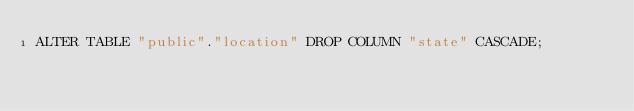Convert code to text. <code><loc_0><loc_0><loc_500><loc_500><_SQL_>ALTER TABLE "public"."location" DROP COLUMN "state" CASCADE;
</code> 